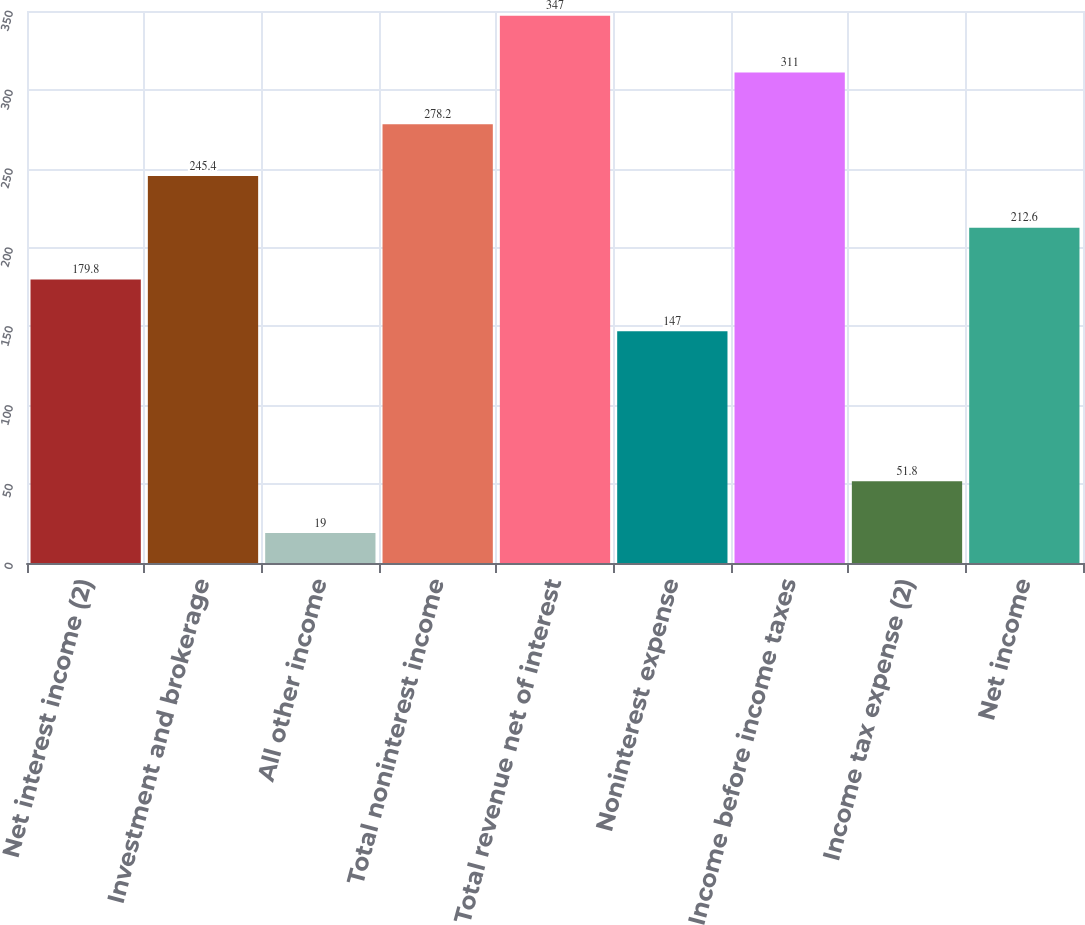<chart> <loc_0><loc_0><loc_500><loc_500><bar_chart><fcel>Net interest income (2)<fcel>Investment and brokerage<fcel>All other income<fcel>Total noninterest income<fcel>Total revenue net of interest<fcel>Noninterest expense<fcel>Income before income taxes<fcel>Income tax expense (2)<fcel>Net income<nl><fcel>179.8<fcel>245.4<fcel>19<fcel>278.2<fcel>347<fcel>147<fcel>311<fcel>51.8<fcel>212.6<nl></chart> 